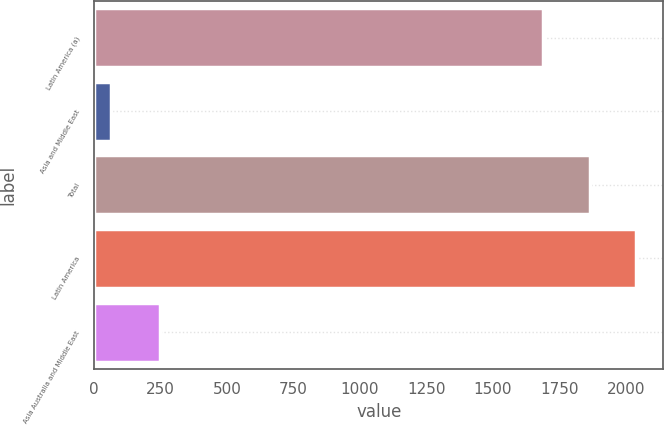Convert chart. <chart><loc_0><loc_0><loc_500><loc_500><bar_chart><fcel>Latin America (a)<fcel>Asia and Middle East<fcel>Total<fcel>Latin America<fcel>Asia Australia and Middle East<nl><fcel>1687.8<fcel>62.3<fcel>1863.99<fcel>2040.18<fcel>249.2<nl></chart> 